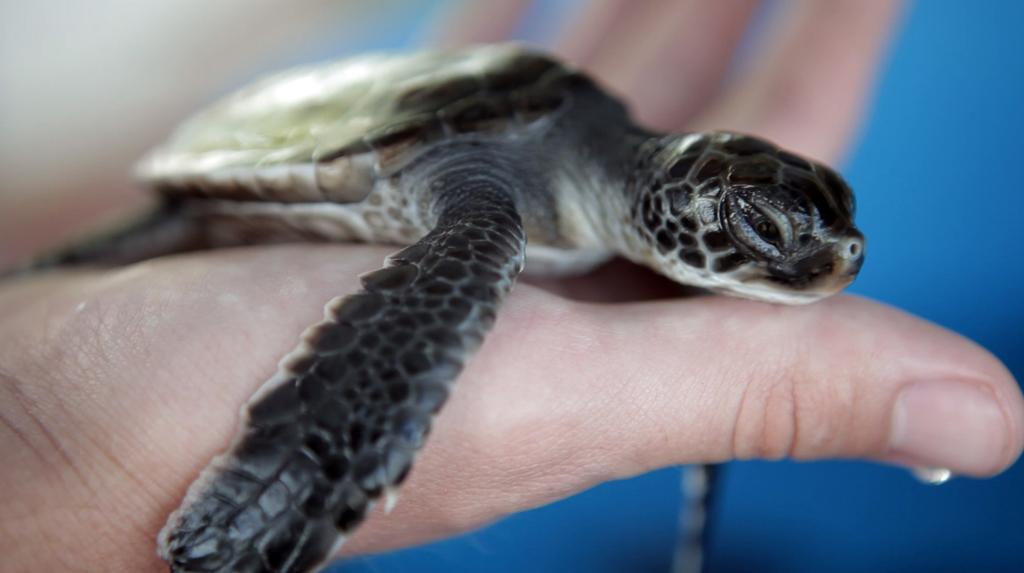Please provide a concise description of this image. This image consists of a turtle in the hand of a person. The background, is blue in color. The turtle is in black color. 